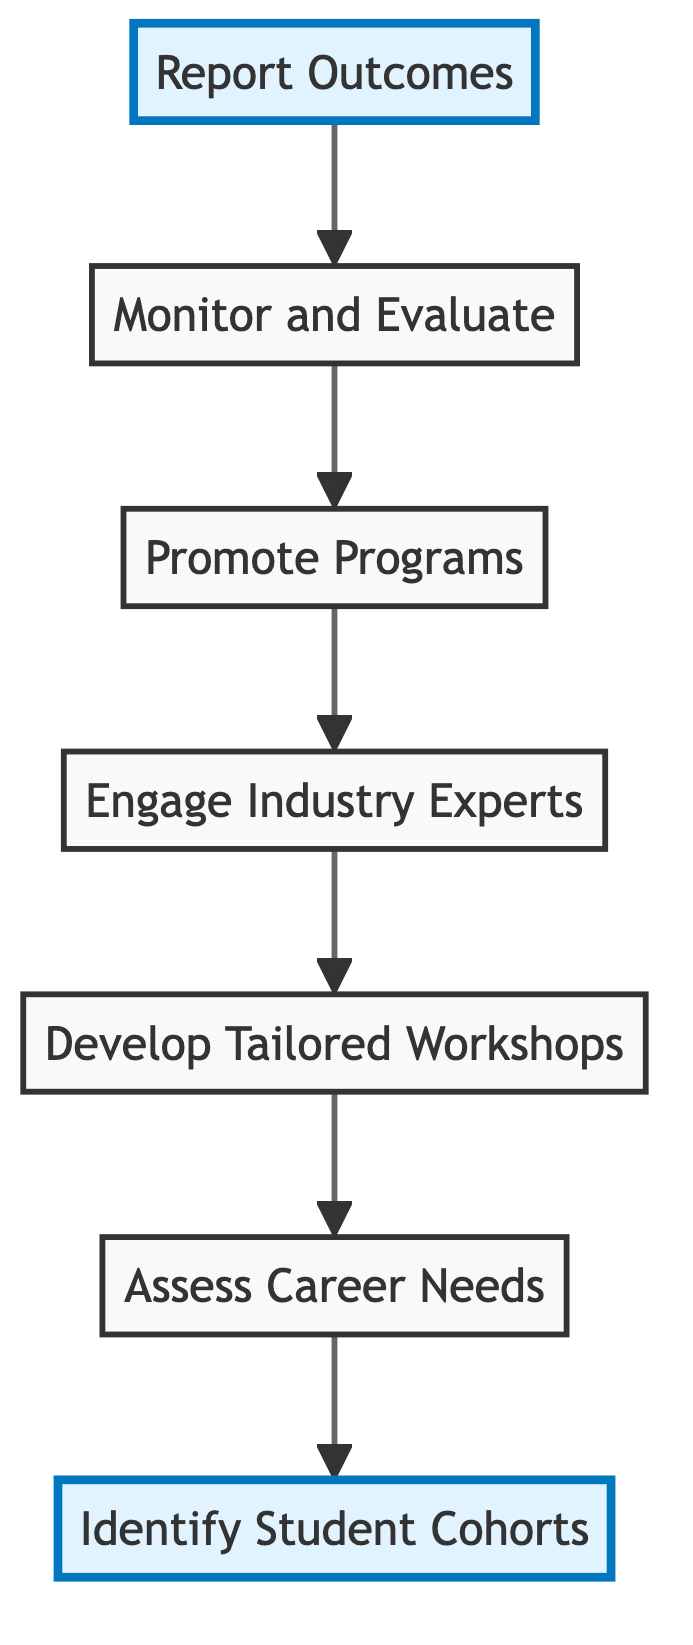What is the first step in the diagram? The first step in the flow chart is represented by the node "Identify Student Cohorts," which is the starting point of the process.
Answer: Identify Student Cohorts How many total nodes are in the diagram? The diagram has a total of 7 nodes: "Identify Student Cohorts," "Assess Career Needs," "Develop Tailored Workshops," "Engage Industry Experts," "Promote Programs," "Monitor and Evaluate," and "Report Outcomes."
Answer: 7 Which node comes after "Engage Industry Experts"? Following the flow of the diagram, the node that comes after "Engage Industry Experts" is "Promote Programs."
Answer: Promote Programs What is the last step in the diagram? The final step or last node indicated in the diagram is "Report Outcomes," representing the concluding action of the process.
Answer: Report Outcomes What are the two main highlighted nodes in the diagram? The highlighted nodes, indicating significant steps in the process, are "Identify Student Cohorts" and "Report Outcomes."
Answer: Identify Student Cohorts, Report Outcomes What is the relationship between "Assess Career Needs" and "Develop Tailored Workshops"? "Assess Career Needs" directly precedes "Develop Tailored Workshops," indicating that the assessment informs the development of the workshops.
Answer: Sequential relationship How does feedback influence the process as depicted in the diagram? Feedback is gathered during "Monitor and Evaluate," which informs necessary improvements to the career workshops and counseling sessions, thereby influencing the earlier steps indirectly.
Answer: Feedback leads to improvements What is the purpose of "Engage Industry Experts" in the process flow? The purpose of "Engage Industry Experts" is to provide real-world insights and mentorship opportunities, which support the effectiveness of the workshops that follow.
Answer: Provide insights and mentorship Which steps must occur before promoting the career programs? Before "Promote Programs," both "Engage Industry Experts" and "Develop Tailored Workshops" must occur, as these build the content that needs promotion.
Answer: Engage Industry Experts, Develop Tailored Workshops 